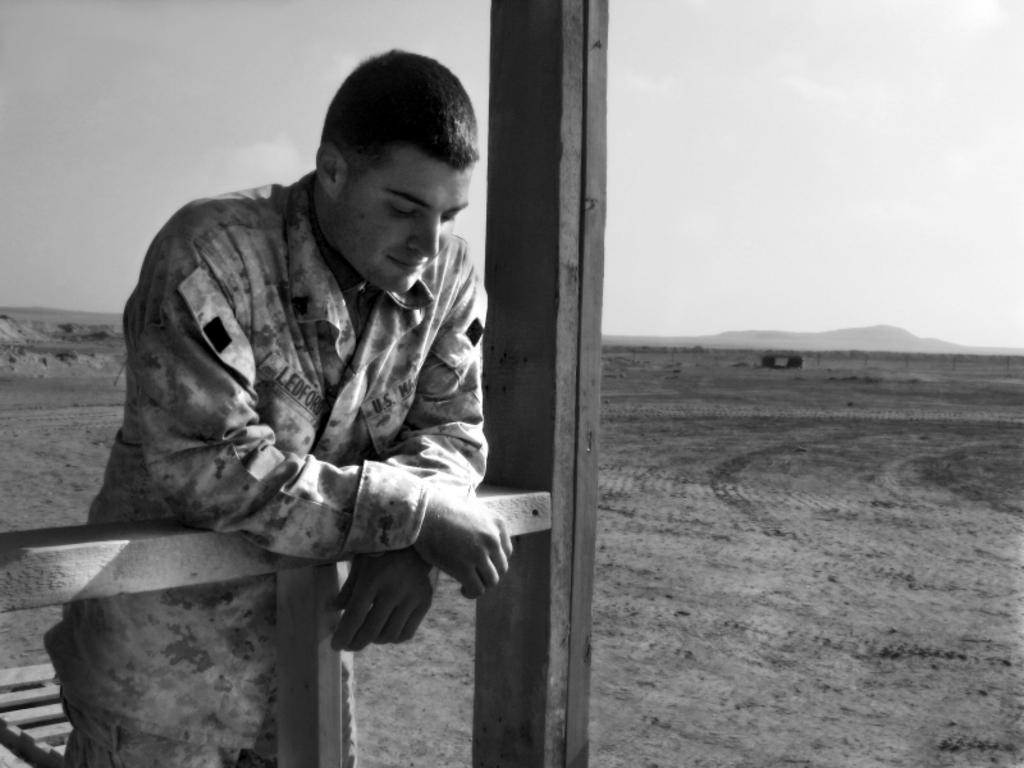Who is present in the image? There is a man in the image. What type of objects can be seen in the image? There are wooden objects in the image. What part of the natural environment is visible in the image? The sky is visible in the image. What type of curtain can be seen hanging from the window in the image? There is no window or curtain present in the image. What is the man using to water the plants in the image? There are no plants or watering tools visible in the image. 